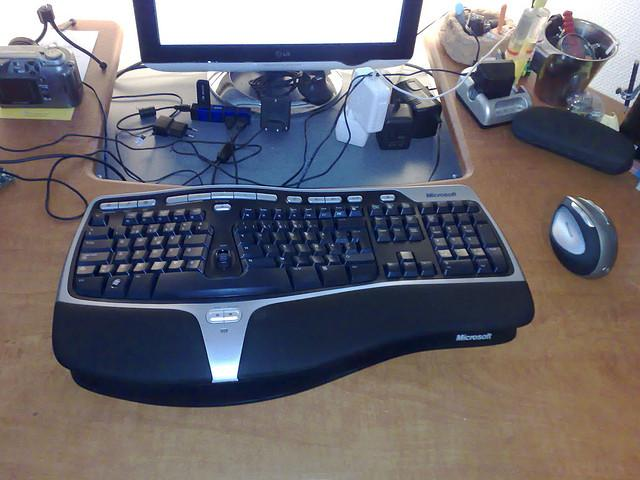What are the corded objects used for? charging 